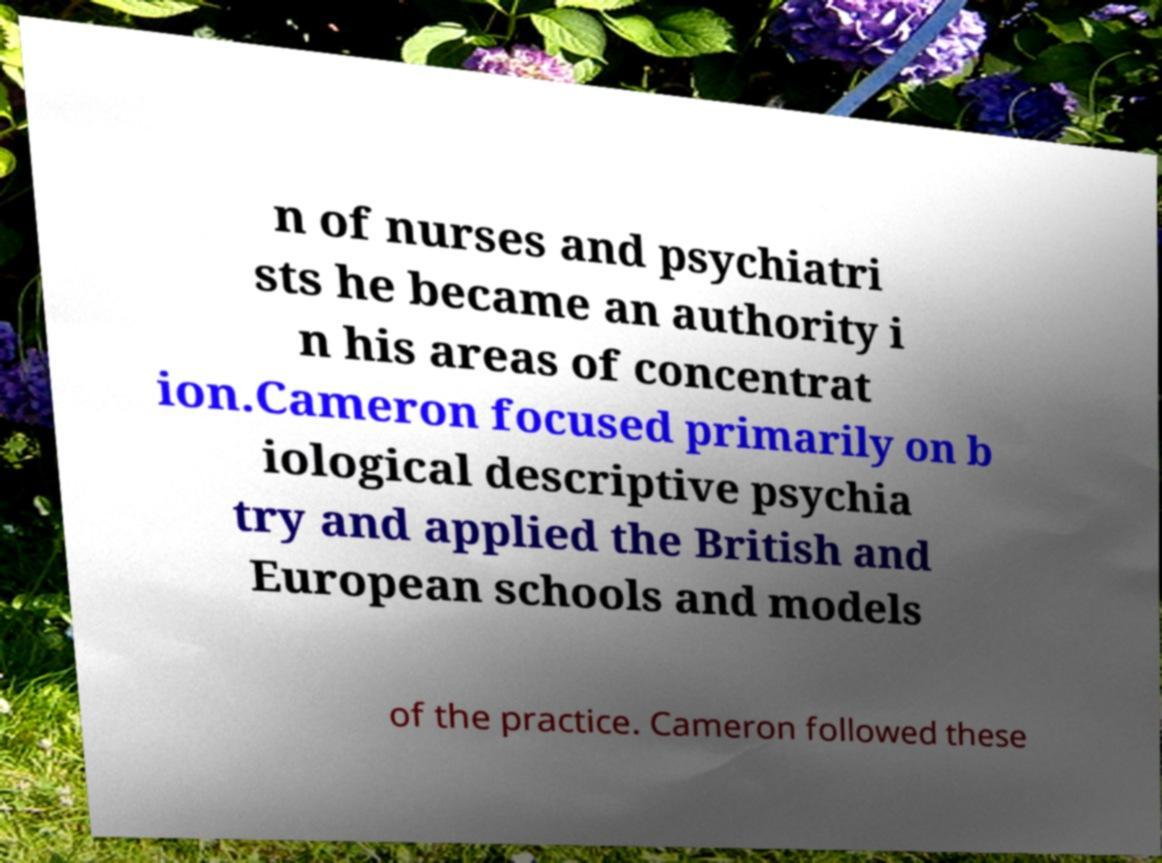Please read and relay the text visible in this image. What does it say? n of nurses and psychiatri sts he became an authority i n his areas of concentrat ion.Cameron focused primarily on b iological descriptive psychia try and applied the British and European schools and models of the practice. Cameron followed these 